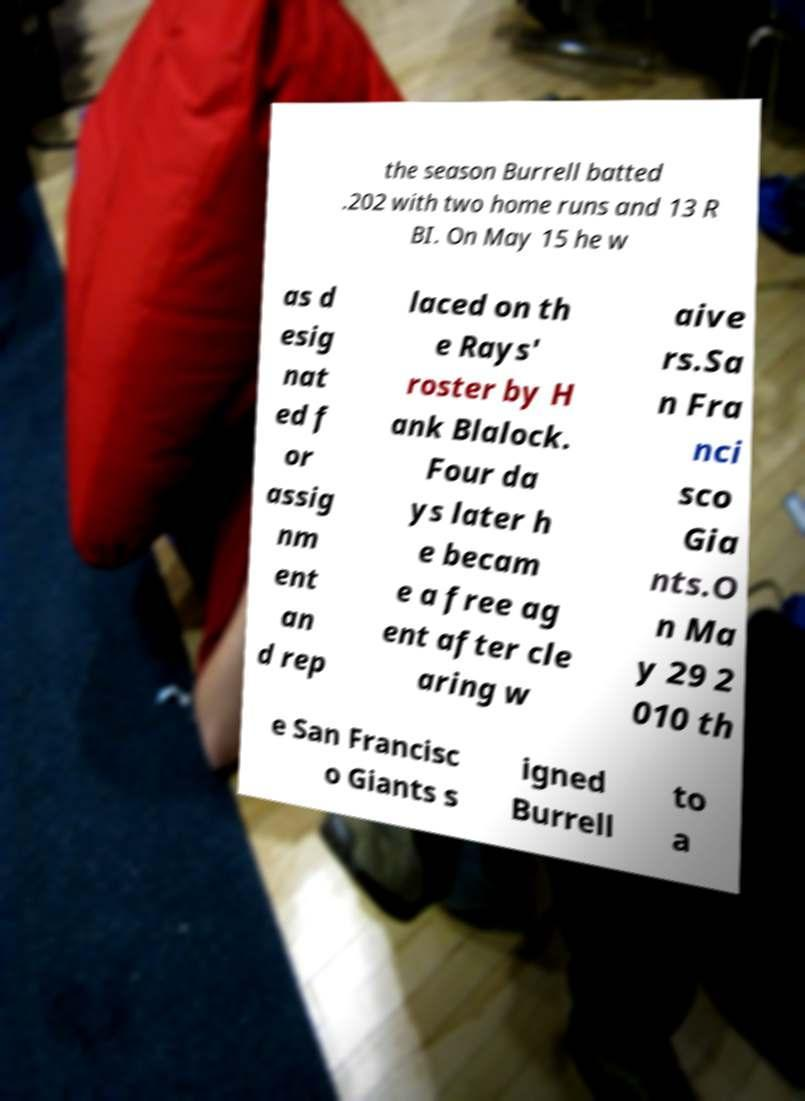There's text embedded in this image that I need extracted. Can you transcribe it verbatim? the season Burrell batted .202 with two home runs and 13 R BI. On May 15 he w as d esig nat ed f or assig nm ent an d rep laced on th e Rays' roster by H ank Blalock. Four da ys later h e becam e a free ag ent after cle aring w aive rs.Sa n Fra nci sco Gia nts.O n Ma y 29 2 010 th e San Francisc o Giants s igned Burrell to a 